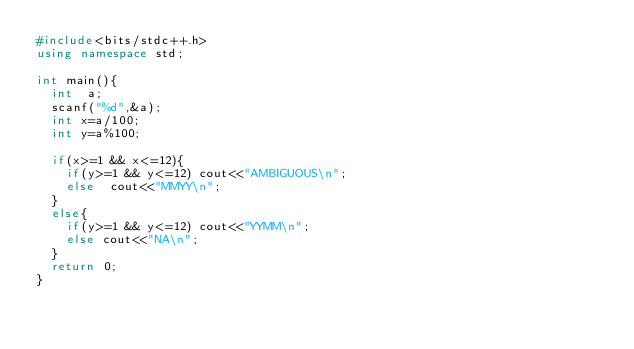<code> <loc_0><loc_0><loc_500><loc_500><_C++_>#include<bits/stdc++.h>
using namespace std;

int main(){
  int  a;
  scanf("%d",&a);
  int x=a/100;
  int y=a%100;

  if(x>=1 && x<=12){
    if(y>=1 && y<=12) cout<<"AMBIGUOUS\n";
    else  cout<<"MMYY\n";
  }
  else{
    if(y>=1 && y<=12) cout<<"YYMM\n";
    else cout<<"NA\n";
  }
  return 0;
}</code> 